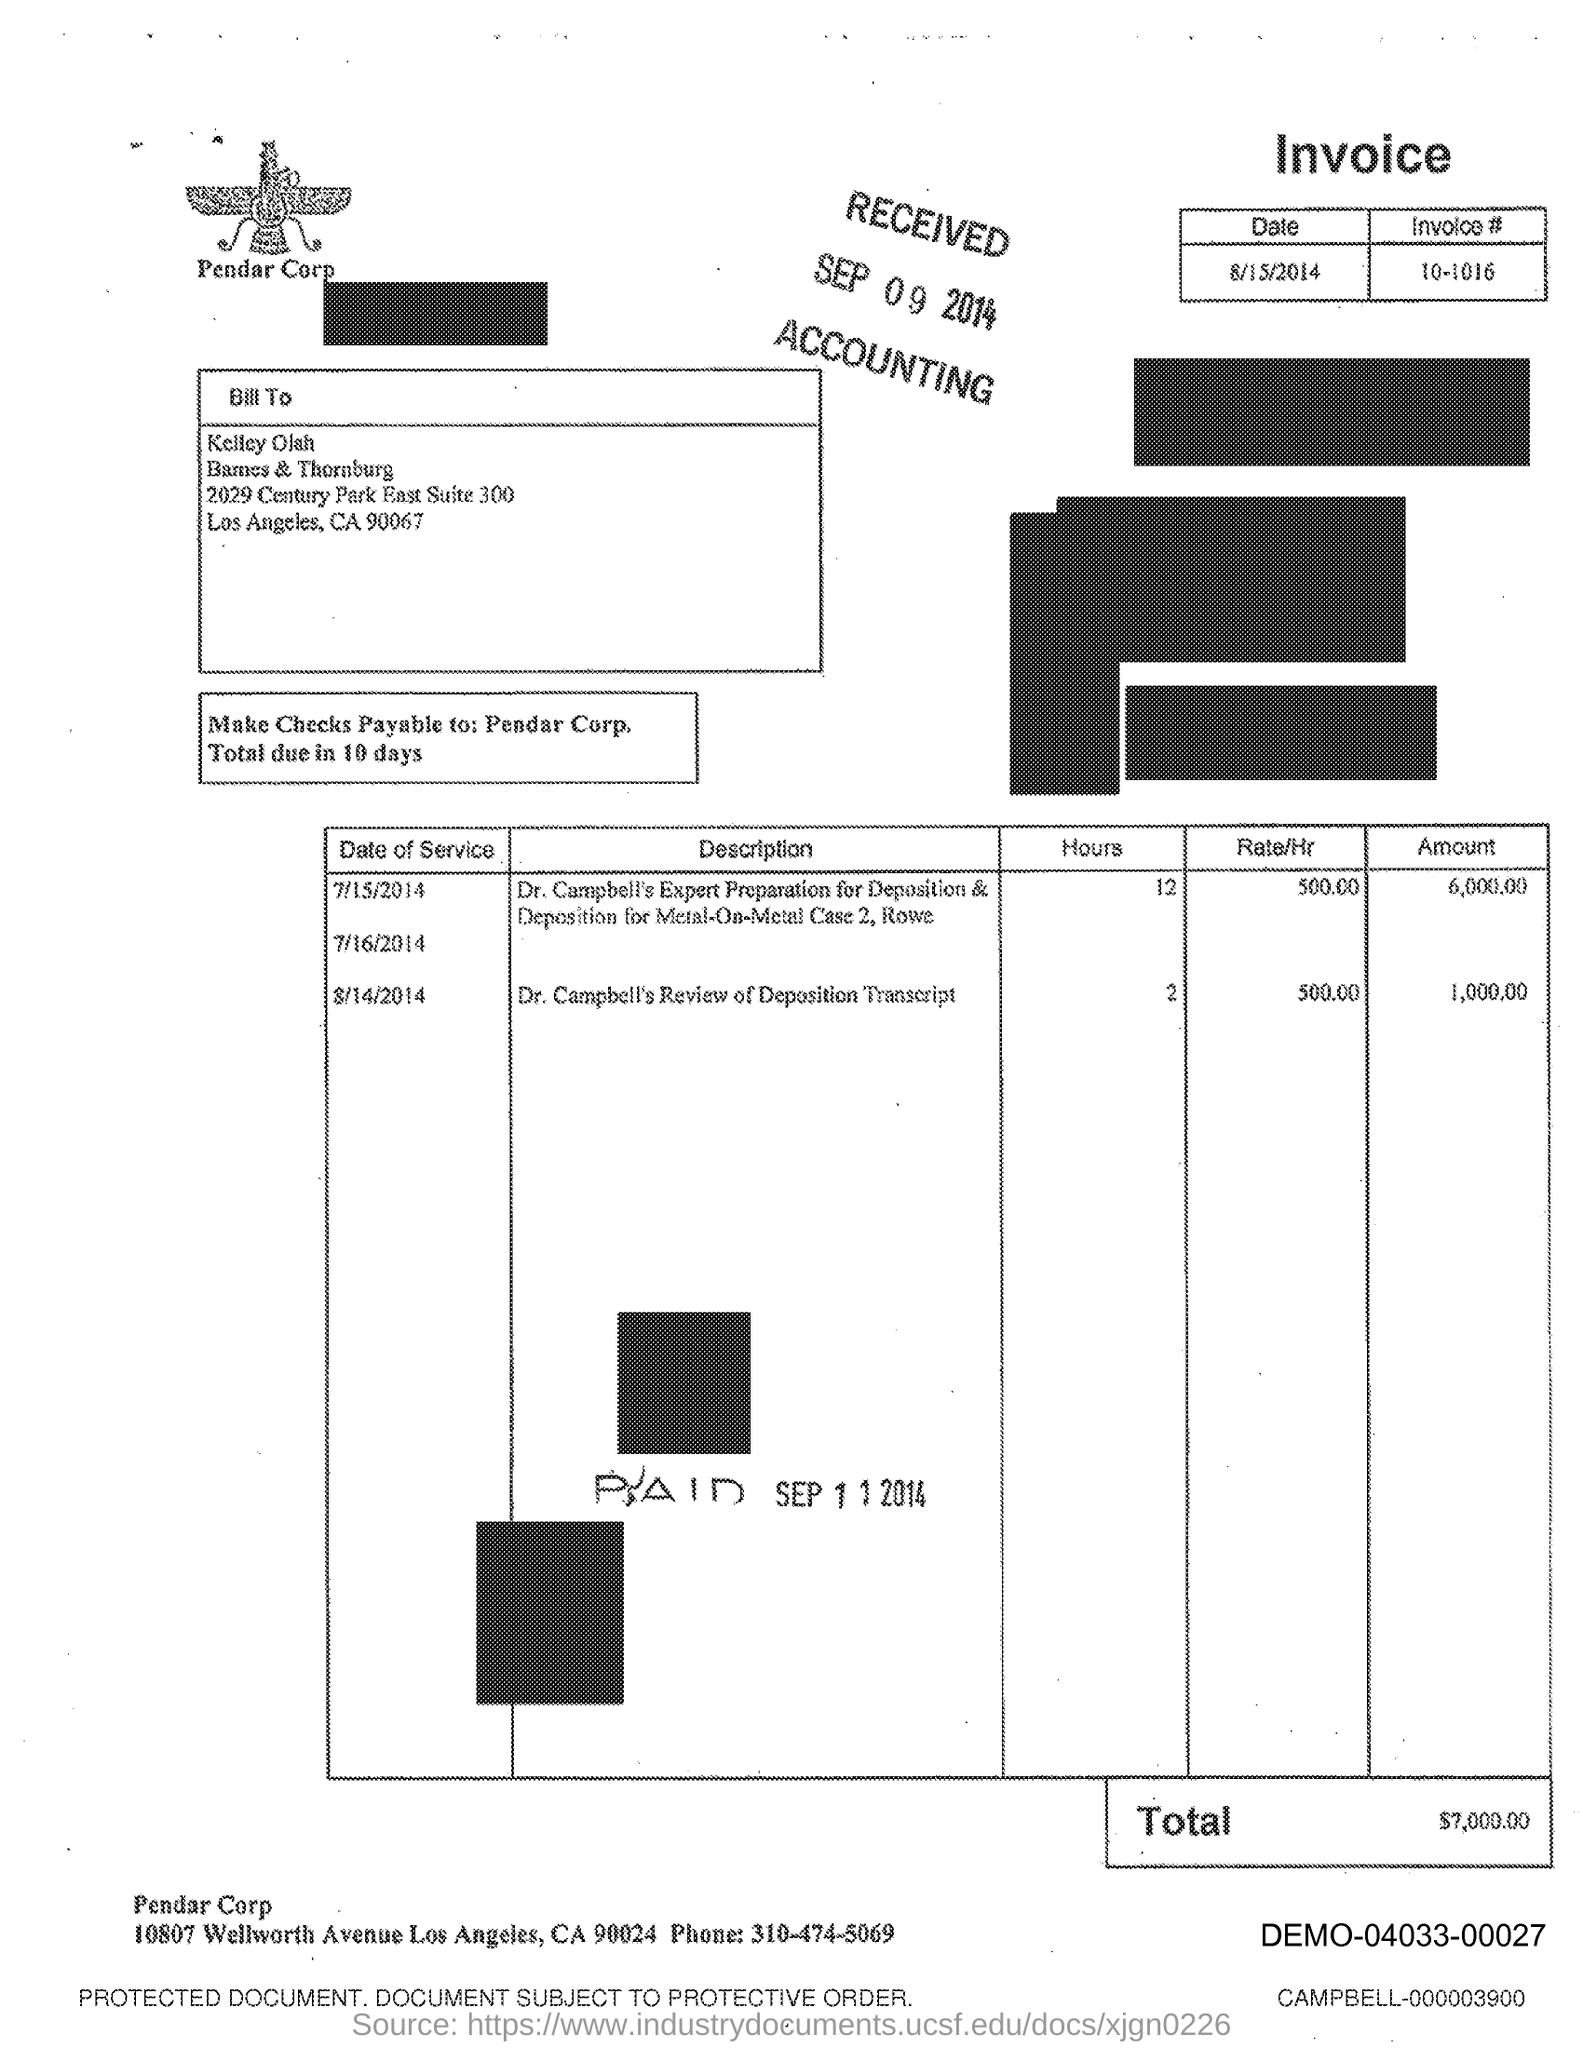List a handful of essential elements in this visual. The payment of checks is required to be made within 10 days. 